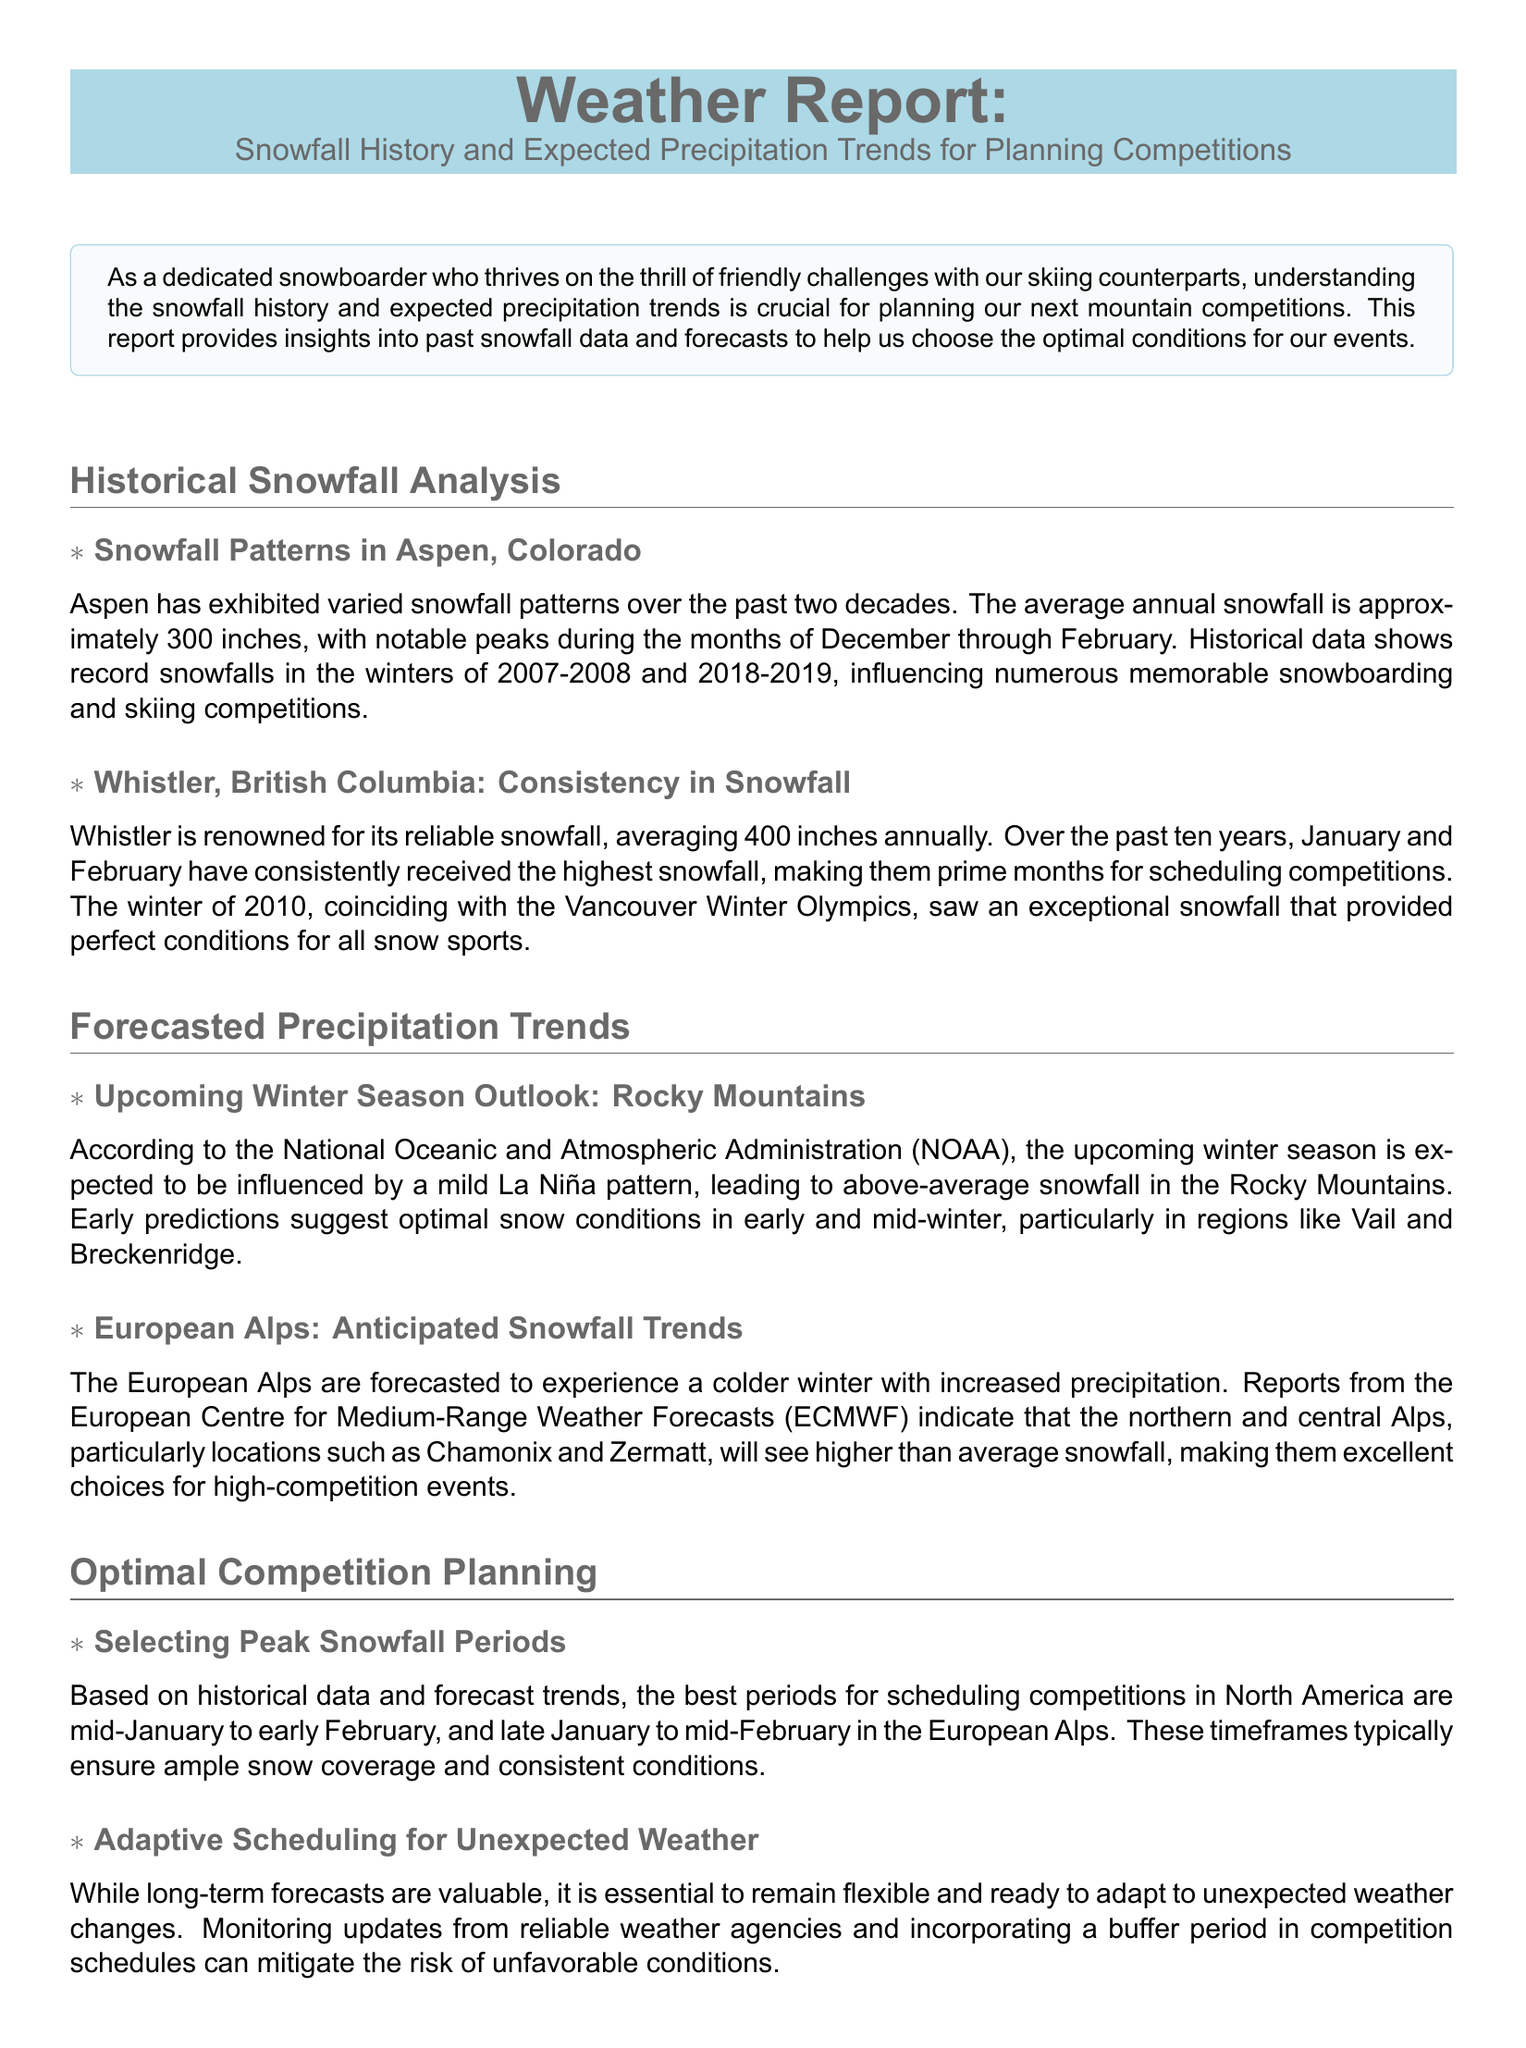What is the average annual snowfall in Aspen? The document states that the average annual snowfall in Aspen is approximately 300 inches.
Answer: 300 inches What were the record snowfalls in Aspen during the winters mentioned? According to the document, the record snowfalls occurred in the winters of 2007-2008 and 2018-2019.
Answer: 2007-2008 and 2018-2019 What is the average annual snowfall in Whistler? It is mentioned in the report that Whistler averages 400 inches of snowfall annually.
Answer: 400 inches Which months in Whistler typically receive the highest snowfall? The report indicates that January and February have consistently received the highest snowfall.
Answer: January and February What weather pattern is expected to influence the upcoming winter season in the Rocky Mountains? The document refers to a mild La Niña pattern expected to influence the winter season.
Answer: La Niña What are the recommended timeframes for scheduling competitions in North America? The best periods for scheduling competitions are mid-January to early February.
Answer: mid-January to early February What is suggested to mitigate the risk of unfavorable conditions during competitions? The document suggests incorporating a buffer period in competition schedules as a measure.
Answer: a buffer period Which specific regions are highlighted for optimal snow conditions in early and mid-winter? The report highlights Vail and Breckenridge as regions with optimal snow conditions.
Answer: Vail and Breckenridge What is the conclusion of the report regarding snowfall history and precipitation trends? The conclusion emphasizes that understanding snowfall history and trends enables better event planning.
Answer: better event planning 